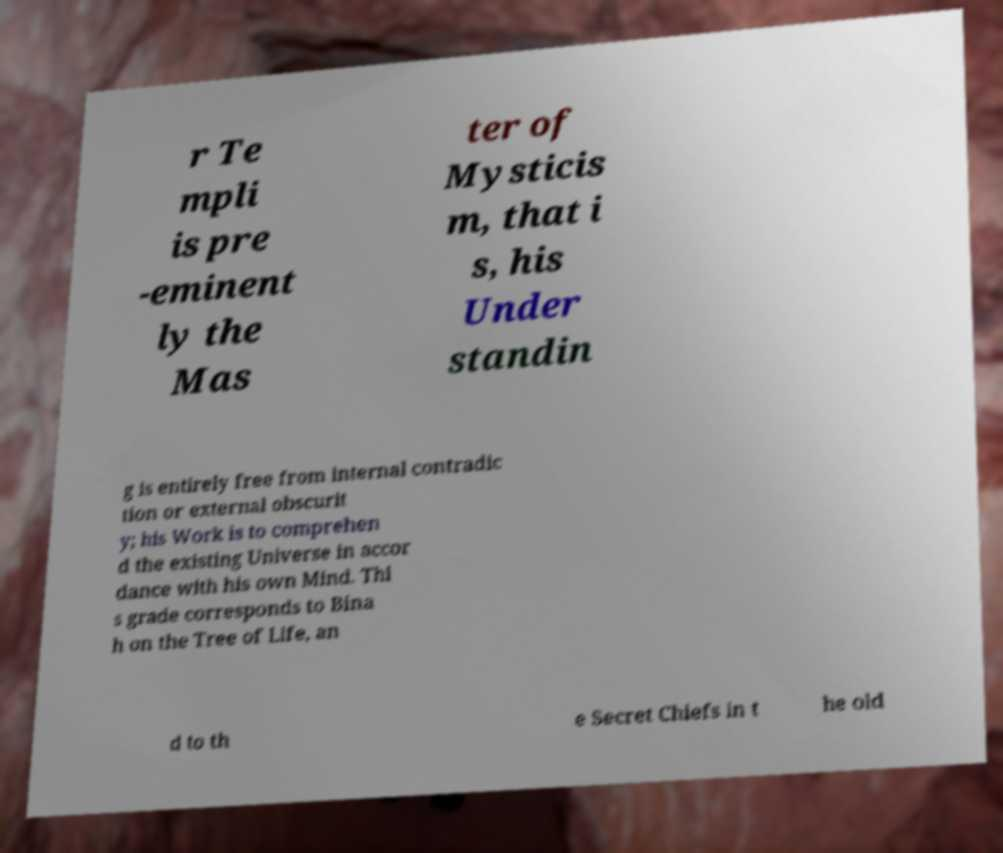Can you read and provide the text displayed in the image?This photo seems to have some interesting text. Can you extract and type it out for me? r Te mpli is pre -eminent ly the Mas ter of Mysticis m, that i s, his Under standin g is entirely free from internal contradic tion or external obscurit y; his Work is to comprehen d the existing Universe in accor dance with his own Mind. Thi s grade corresponds to Bina h on the Tree of Life, an d to th e Secret Chiefs in t he old 